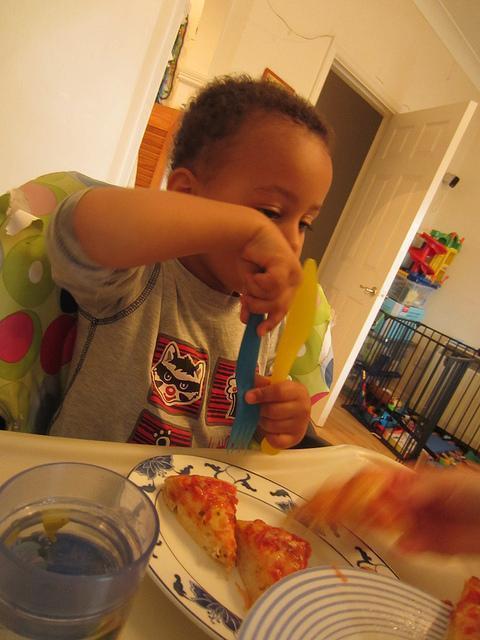How many people can you see?
Give a very brief answer. 2. 